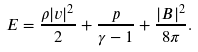Convert formula to latex. <formula><loc_0><loc_0><loc_500><loc_500>E = \frac { \rho | { v } | ^ { 2 } } { 2 } + \frac { p } { \gamma - 1 } + \frac { | { B } | ^ { 2 } } { 8 \pi } .</formula> 